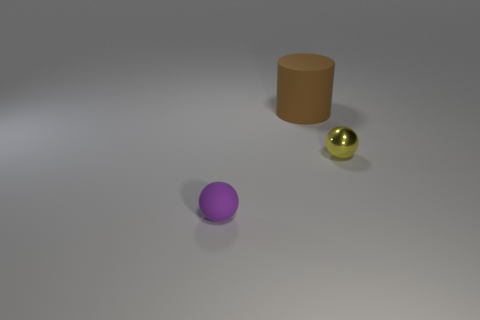What is the ball on the left side of the yellow object made of?
Offer a very short reply. Rubber. Are there the same number of brown rubber things that are on the left side of the brown matte thing and large cylinders?
Offer a terse response. No. Is the brown thing the same shape as the tiny yellow object?
Ensure brevity in your answer.  No. Are there any other things that have the same color as the metal thing?
Provide a succinct answer. No. There is a object that is both behind the matte ball and on the left side of the small shiny ball; what shape is it?
Give a very brief answer. Cylinder. Is the number of small yellow metal things left of the small yellow thing the same as the number of balls on the right side of the purple ball?
Your response must be concise. No. How many spheres are either purple rubber objects or big brown things?
Provide a short and direct response. 1. What number of large brown cylinders are the same material as the tiny purple sphere?
Make the answer very short. 1. There is a thing that is on the left side of the metallic object and behind the matte ball; what is its material?
Make the answer very short. Rubber. What shape is the small object that is in front of the small yellow sphere?
Offer a very short reply. Sphere. 